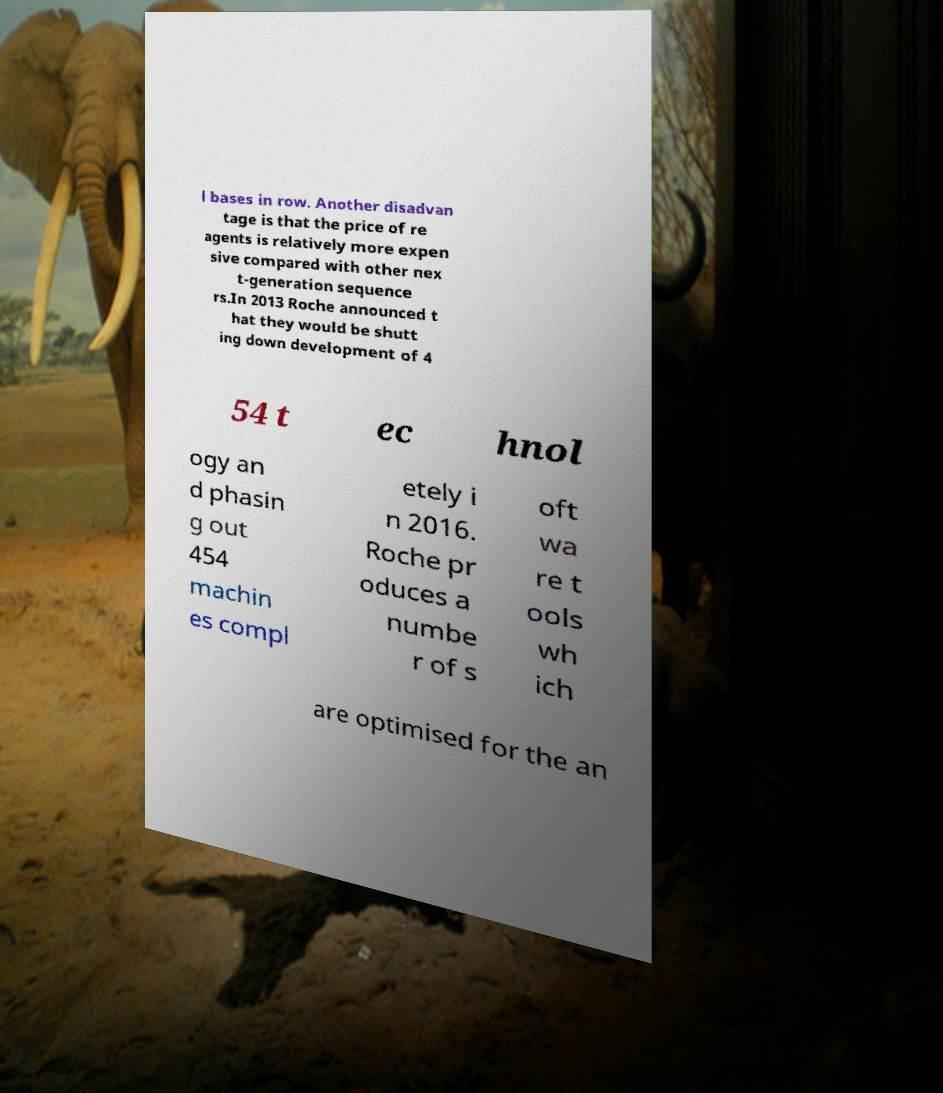Can you read and provide the text displayed in the image?This photo seems to have some interesting text. Can you extract and type it out for me? l bases in row. Another disadvan tage is that the price of re agents is relatively more expen sive compared with other nex t-generation sequence rs.In 2013 Roche announced t hat they would be shutt ing down development of 4 54 t ec hnol ogy an d phasin g out 454 machin es compl etely i n 2016. Roche pr oduces a numbe r of s oft wa re t ools wh ich are optimised for the an 